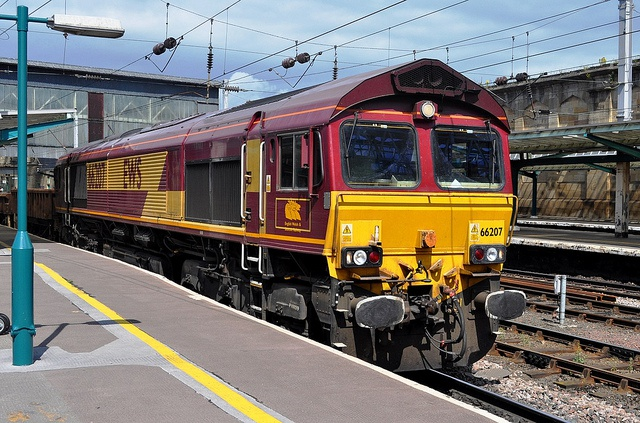Describe the objects in this image and their specific colors. I can see a train in lightblue, black, gray, maroon, and orange tones in this image. 